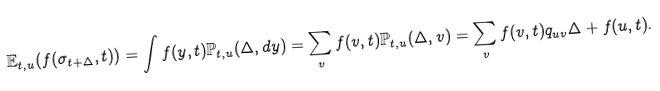<formula> <loc_0><loc_0><loc_500><loc_500>\mathbb { E } _ { t , u } ( f ( \sigma _ { t + \Delta } , t ) ) = \int f ( y , t ) \mathbb { P } _ { t , u } ( \Delta , d y ) = \sum _ { v } f ( v , t ) \mathbb { P } _ { t , u } ( \Delta , v ) = \sum _ { v } f ( v , t ) q _ { u v } \Delta + f ( u , t ) .</formula> 